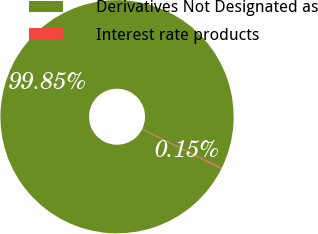<chart> <loc_0><loc_0><loc_500><loc_500><pie_chart><fcel>Derivatives Not Designated as<fcel>Interest rate products<nl><fcel>99.85%<fcel>0.15%<nl></chart> 